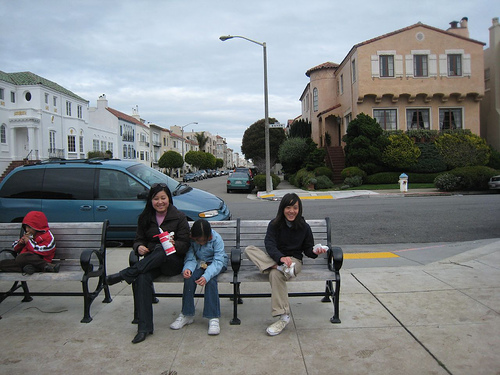What's the weather like in this scene? The weather appears to be overcast, as evidenced by the grey skies and the apparent lack of shadows. The individuals are dressed in light to moderate attire, suggesting it is not particularly cold. Altogether, the ambiance is that of a cooler day without rain, where it's comfortable to sit outdoors without the need for heavy jackets or sun protection. 